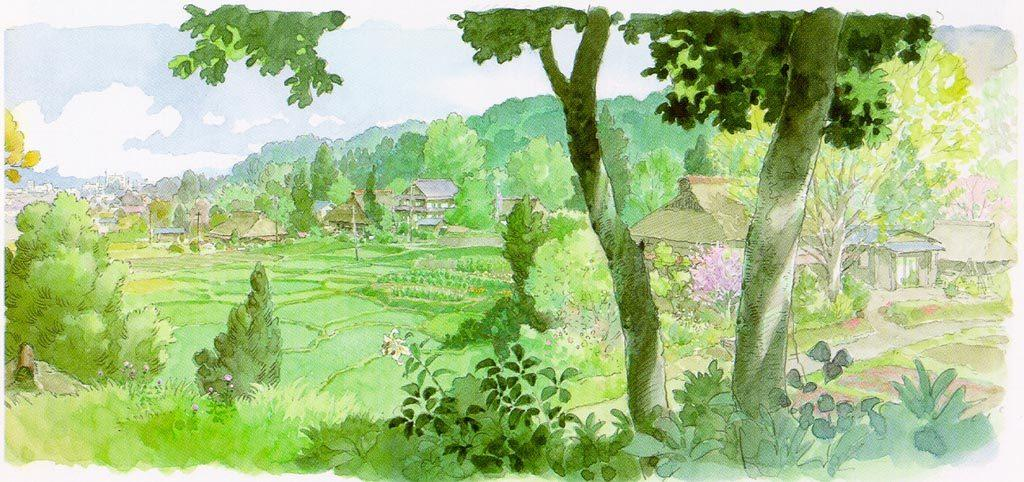What is the main subject of the image? The image contains a painting. What elements are present in the painting? There are trees, houses, clouds, and a blue sky in the painting. What caption is written below the painting in the image? There is no caption visible in the image; it only contains the painting itself. 